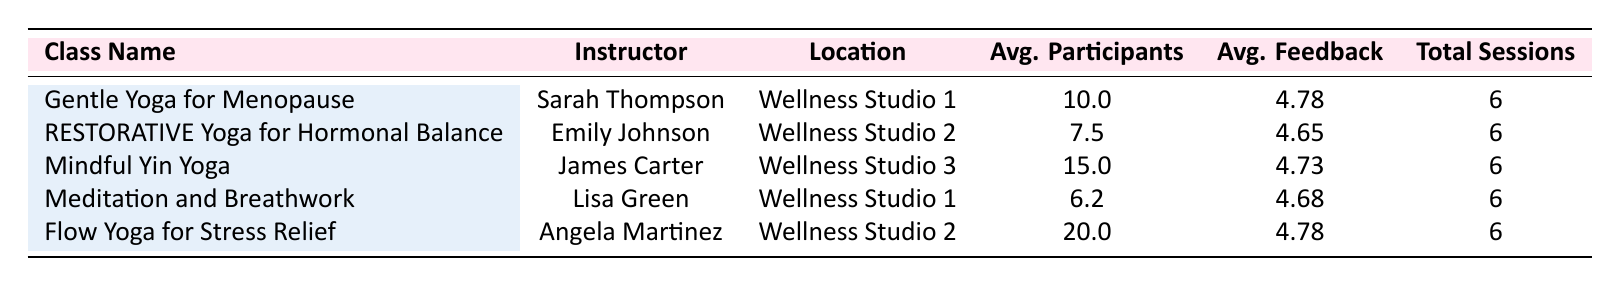What is the name of the instructor for "Flow Yoga for Stress Relief"? The table lists the instructors for each class, and "Flow Yoga for Stress Relief" is taught by Angela Martinez.
Answer: Angela Martinez Which class had the highest average number of participants? In the table, the average number of participants for "Flow Yoga for Stress Relief" is 20.0, compared to the other classes.
Answer: Flow Yoga for Stress Relief What is the average feedback rating for "Mindful Yin Yoga"? The table shows an average feedback rating of 4.73 for "Mindful Yin Yoga."
Answer: 4.73 Is the average feedback for "Gentle Yoga for Menopause" higher than that for "RESTORATIVE Yoga for Hormonal Balance"? The average feedback for "Gentle Yoga for Menopause" is 4.78 while "RESTORATIVE Yoga for Hormonal Balance" has an average of 4.65. Thus, Gentle Yoga has higher feedback.
Answer: Yes What is the total number of sessions conducted for "Meditation and Breathwork"? The table indicates that "Meditation and Breathwork" had a total of 6 sessions.
Answer: 6 Calculate the difference in average participants between "Mindful Yin Yoga" and "Meditation and Breathwork." The average for "Mindful Yin Yoga" is 15.0 and for "Meditation and Breathwork" it is 6.2. The difference is 15.0 - 6.2 = 8.8.
Answer: 8.8 Which class had the lowest average feedback rating? From the averages listed, "RESTORATIVE Yoga for Hormonal Balance" has the lowest average feedback at 4.65.
Answer: RESTORATIVE Yoga for Hormonal Balance If the "Gentle Yoga for Menopause" class had one more session with 12 participants and a feedback score of 4.9, what would the new average participants and average feedback be? The current total participants for "Gentle Yoga" is (10.0 * 6) = 60 and with one more session of 12, the new total is 72 with 7 sessions. The average participants becomes 72 / 7 = 10.29. For feedback: (4.78 * 6 + 4.9) / 7 = 4.79.
Answer: 10.29 participants and 4.79 feedback Which location has the highest attendance average? Summing the average participants for classes in each location, Wellness Studio 1 is 10.0 for Gentle Yoga and 6.2 for Meditation; totaling 16.2. Wellness Studio 2 averages 7.5 for RESTORATIVE and 20.0 for Flow; total is 27.5. Studio 3 averages 15.0. Thus, Studio 2 has the highest attendance average.
Answer: Wellness Studio 2 How many classes have an average feedback rating of 4.7 or higher? The classes with average feedback ratings of 4.7 or higher are Gentle Yoga (4.78), Mindful Yin Yoga (4.73), and Flow Yoga for Stress Relief (4.78). That's a total of 3 classes.
Answer: 3 classes 